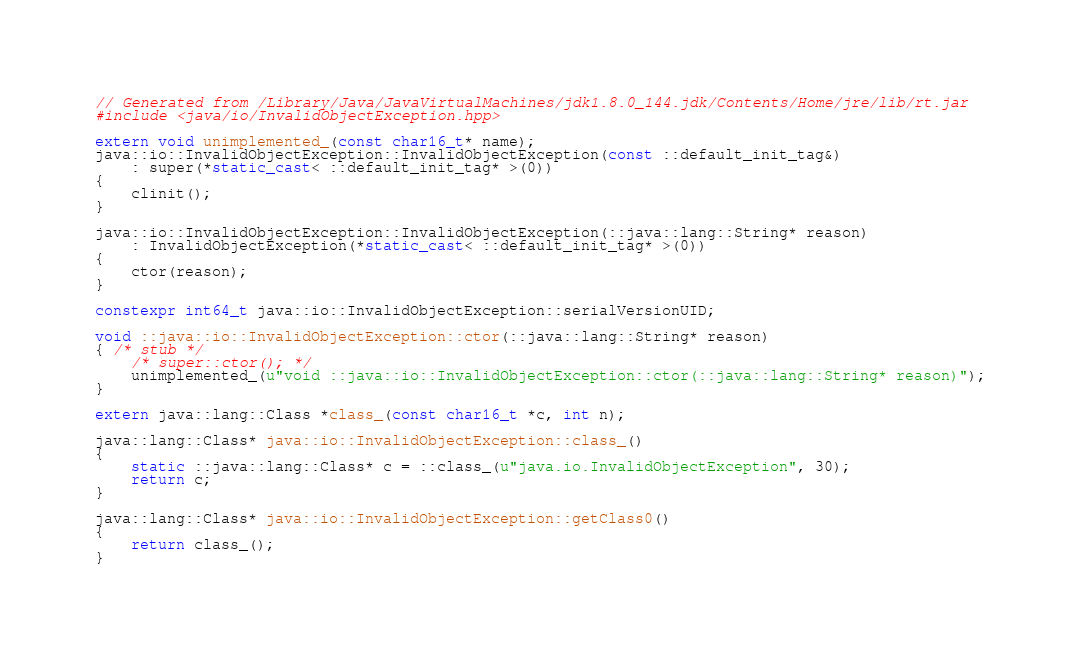<code> <loc_0><loc_0><loc_500><loc_500><_C++_>// Generated from /Library/Java/JavaVirtualMachines/jdk1.8.0_144.jdk/Contents/Home/jre/lib/rt.jar
#include <java/io/InvalidObjectException.hpp>

extern void unimplemented_(const char16_t* name);
java::io::InvalidObjectException::InvalidObjectException(const ::default_init_tag&)
    : super(*static_cast< ::default_init_tag* >(0))
{
    clinit();
}

java::io::InvalidObjectException::InvalidObjectException(::java::lang::String* reason)
    : InvalidObjectException(*static_cast< ::default_init_tag* >(0))
{
    ctor(reason);
}

constexpr int64_t java::io::InvalidObjectException::serialVersionUID;

void ::java::io::InvalidObjectException::ctor(::java::lang::String* reason)
{ /* stub */
    /* super::ctor(); */
    unimplemented_(u"void ::java::io::InvalidObjectException::ctor(::java::lang::String* reason)");
}

extern java::lang::Class *class_(const char16_t *c, int n);

java::lang::Class* java::io::InvalidObjectException::class_()
{
    static ::java::lang::Class* c = ::class_(u"java.io.InvalidObjectException", 30);
    return c;
}

java::lang::Class* java::io::InvalidObjectException::getClass0()
{
    return class_();
}

</code> 